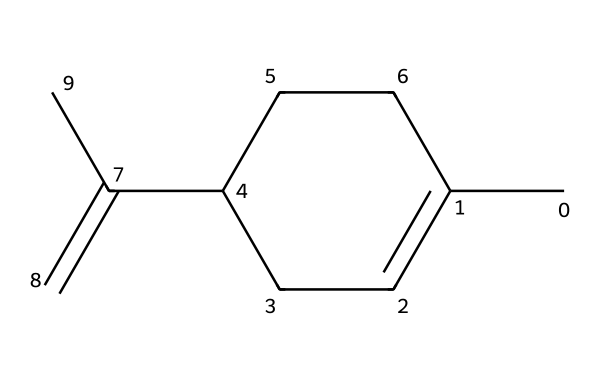What is the total number of carbon atoms in this chemical structure? By analyzing the provided SMILES notation, we count the number of carbon atoms represented. The notation indicates a total of 10 carbon atoms (each "C" denotes a carbon atom, and there are various branching points, but they still count among the total).
Answer: 10 What type of chemical structure is represented by this SMILES notation? The notation describes a cyclic compound because of the presence of "C1" indicating a ring. Additionally, it features a double bond (C(=C)), which is characteristic of alkenes. Thus, it is a cyclic alkene.
Answer: cyclic alkene How many double bonds are present in this chemical structure? In the SMILES representation, we observe only one instance of "C(=C)", indicating a single double bond. There are no other mentions of double bonds in the molecular structure.
Answer: 1 What type of functional group is likely prominent in this chemical? The branched structure along with the presence of a double bond suggests that this chemical may have a significant unsaturation and can represent certain aromatic or aliphatic compounds, but primarily, it points towards alkenes.
Answer: alkene Is this chemical likely to be hydrophilic or hydrophobic? Given that the structure is predominantly composed of carbon and hydrogen with notable multiple carbon (C) and hydrogen (H) connections, it is likely hydrophobic. Aromatic components typically exhibit low affinity for water, favoring oil-soluble properties.
Answer: hydrophobic What is the degree of saturation in this chemical structure? The chemical's ring and the presence of one double bond mean it is unsaturated. For cyclic hydrocarbons, the degree of saturation decreases, thus indicating a lower number of hydrogen atoms in comparison to a fully saturated structure.
Answer: unsaturated 